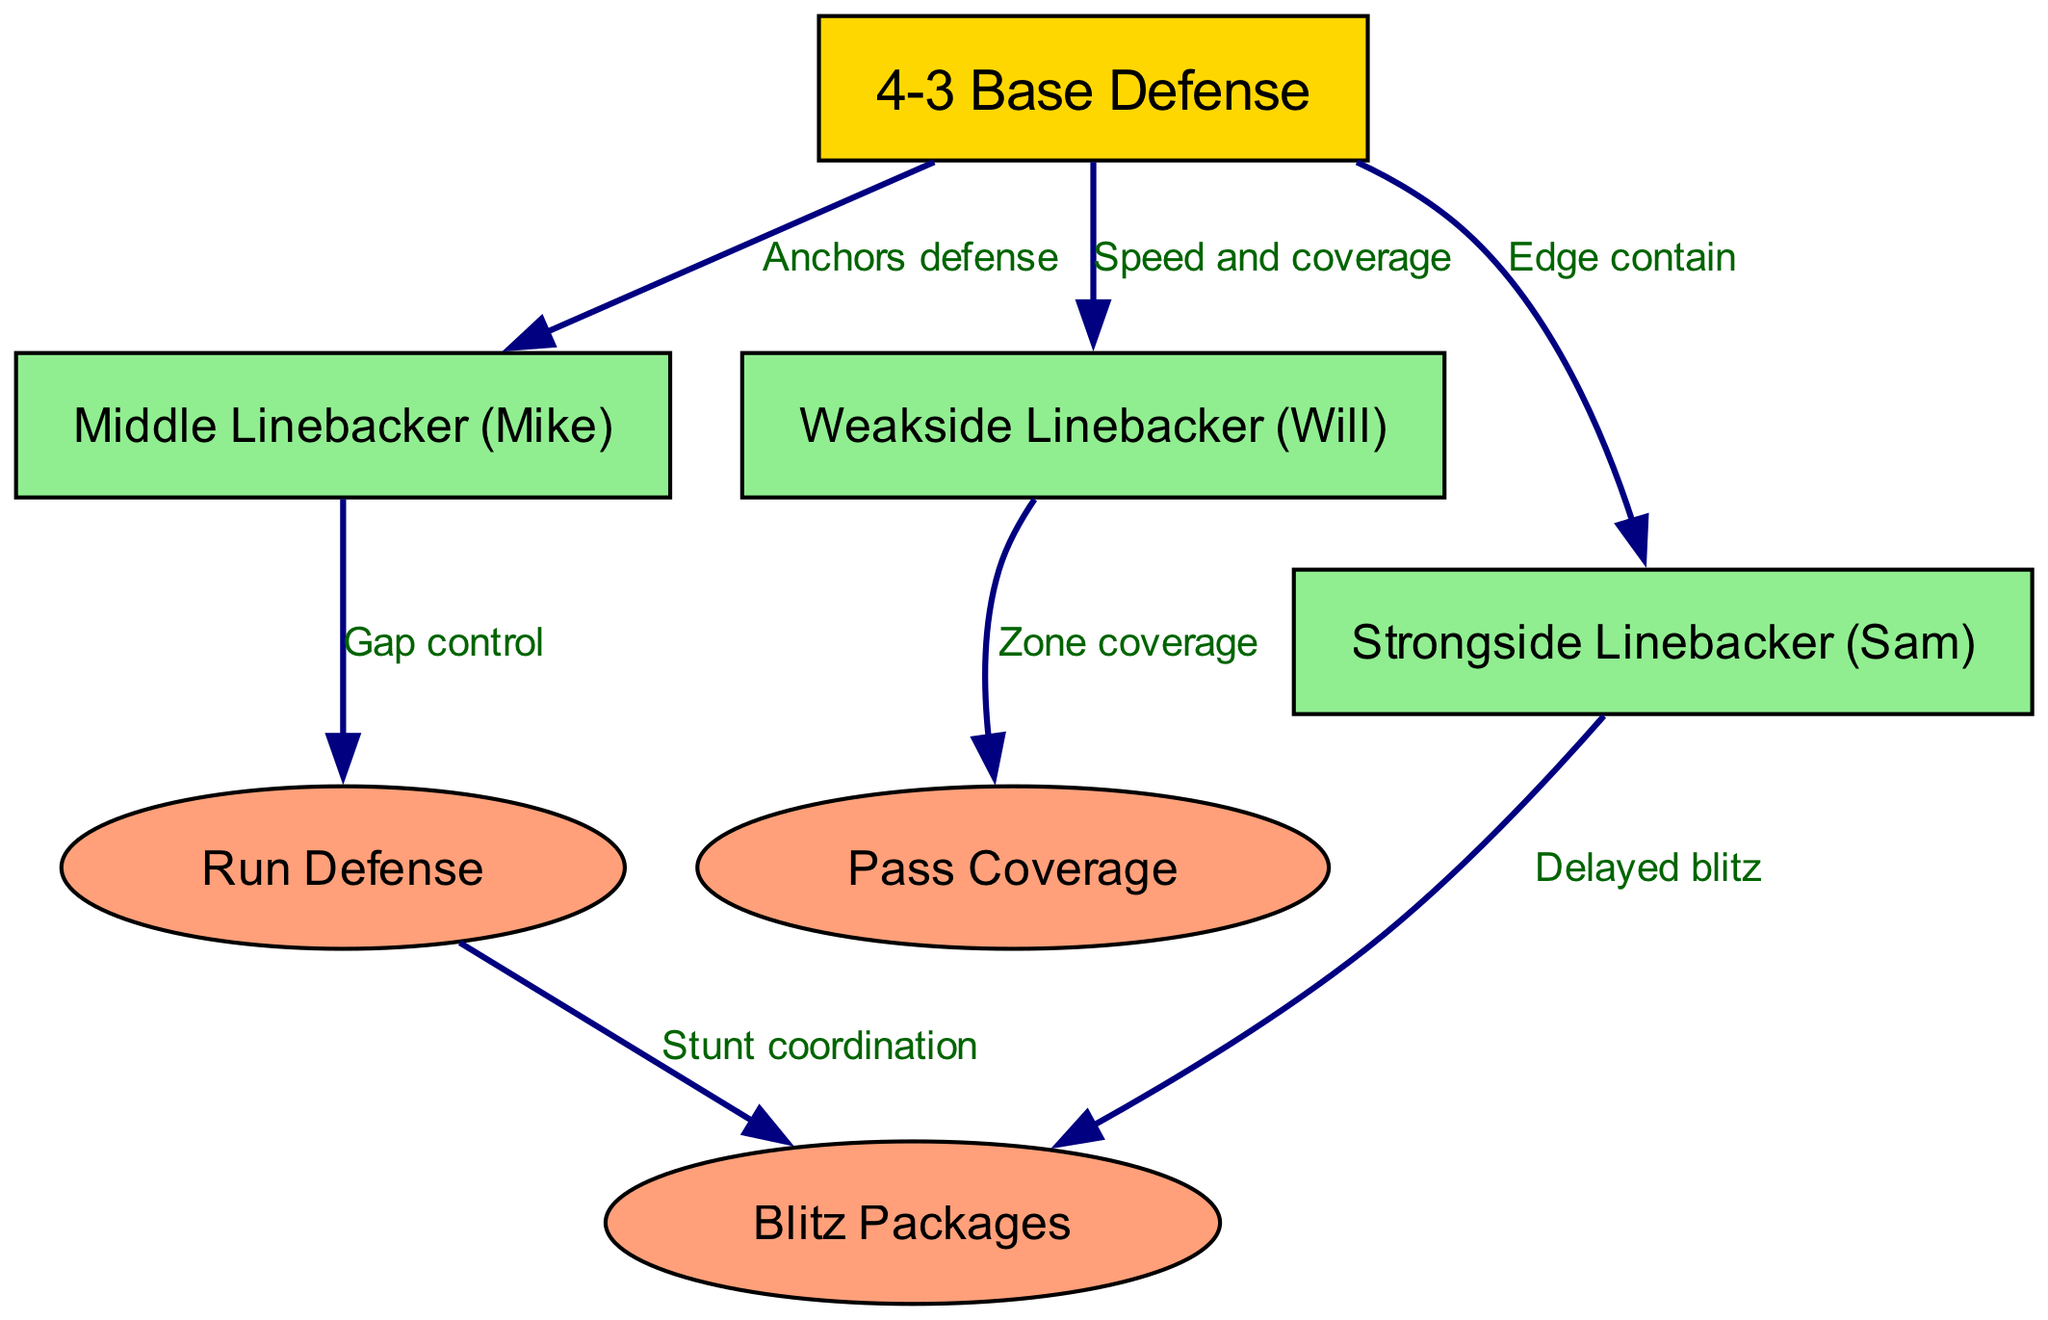What is the primary defensive alignment shown in the diagram? The diagram indicates a "4-3 Base Defense" as the overarching alignment, which is located at the top of the diagram and serves as the foundational structure for the other nodes.
Answer: 4-3 Base Defense How many linebackers are represented in the diagram? The diagram includes three specific linebackers: Middle Linebacker (Mike), Weakside Linebacker (Will), and Strongside Linebacker (Sam), which can be counted directly from the nodes.
Answer: Three What role does the Middle Linebacker (Mike) play in relation to Run Defense? The diagram shows a direct edge from the Middle Linebacker (Mike) to "Run Defense" labeled "Gap control," indicating that the Mike has a specific responsibility in controlling gaps during run plays.
Answer: Gap control Which linebacker is associated with zone coverage? The Weakside Linebacker (Will) is linked to "Pass Coverage" and labeled with "Zone coverage," indicating this specific responsibility in the context of pass defense.
Answer: Weakside Linebacker (Will) How does the Strongside Linebacker (Sam) contribute to blitz packages? The Strongside Linebacker (Sam) has a direct connection to "Blitz Packages" labeled "Delayed blitz," suggesting that he is responsible for executing delayed blitzes as part of his duties.
Answer: Delayed blitz What type of coverage does the Weakside Linebacker focus on? The diagram indicates that the Weakside Linebacker (Will) is associated with "Zone coverage," providing insight into this specific defensive strategy he employs.
Answer: Zone coverage How does "Run Defense" relate to "Blitz Packages"? The diagram shows that "Run Defense" is connected to "Blitz Packages" through "Stunt coordination," indicating that strategies for run defense may involve coordinated stunts during blitz situations.
Answer: Stunt coordination What is the purpose of the edge connection from 4-3 Base Defense to Strongside Linebacker? The diagram states that the Strongside Linebacker (Sam) is responsible for "Edge contain," meaning his role includes maintaining outside containment against opposing plays, highlighted by the edge connection.
Answer: Edge contain 